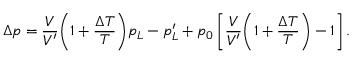<formula> <loc_0><loc_0><loc_500><loc_500>\Delta p = \frac { V } { V ^ { \prime } } { \left ( 1 + \frac { \Delta T } { T } \right ) } p _ { L } - p _ { L } ^ { \prime } + p _ { 0 } \left [ \frac { V } { V ^ { \prime } } { \left ( 1 + \frac { \Delta T } { T } \right ) } - 1 \right ] .</formula> 